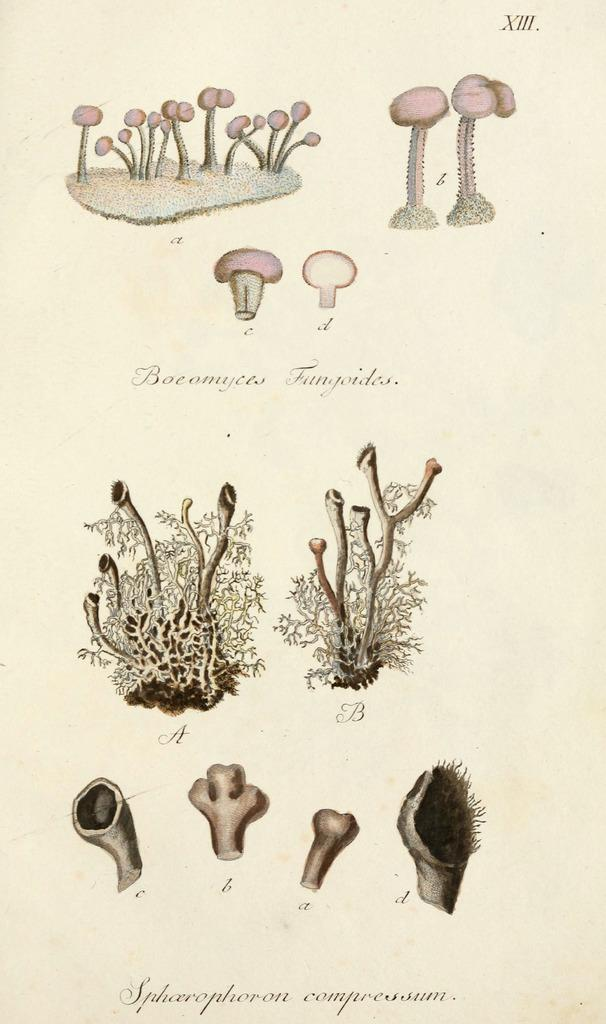What is depicted on the paper in the image? There are mushrooms and plants drawn on the paper. What is the color of the paper? The paper is white. Are there any words written on the paper? Yes, there is text written on the paper. What is the condition of the bed in the image? There is no bed present in the image. How many thumbs are visible on the paper? There are no thumbs depicted on the paper; it features drawings of mushrooms and plants, as well as text. 